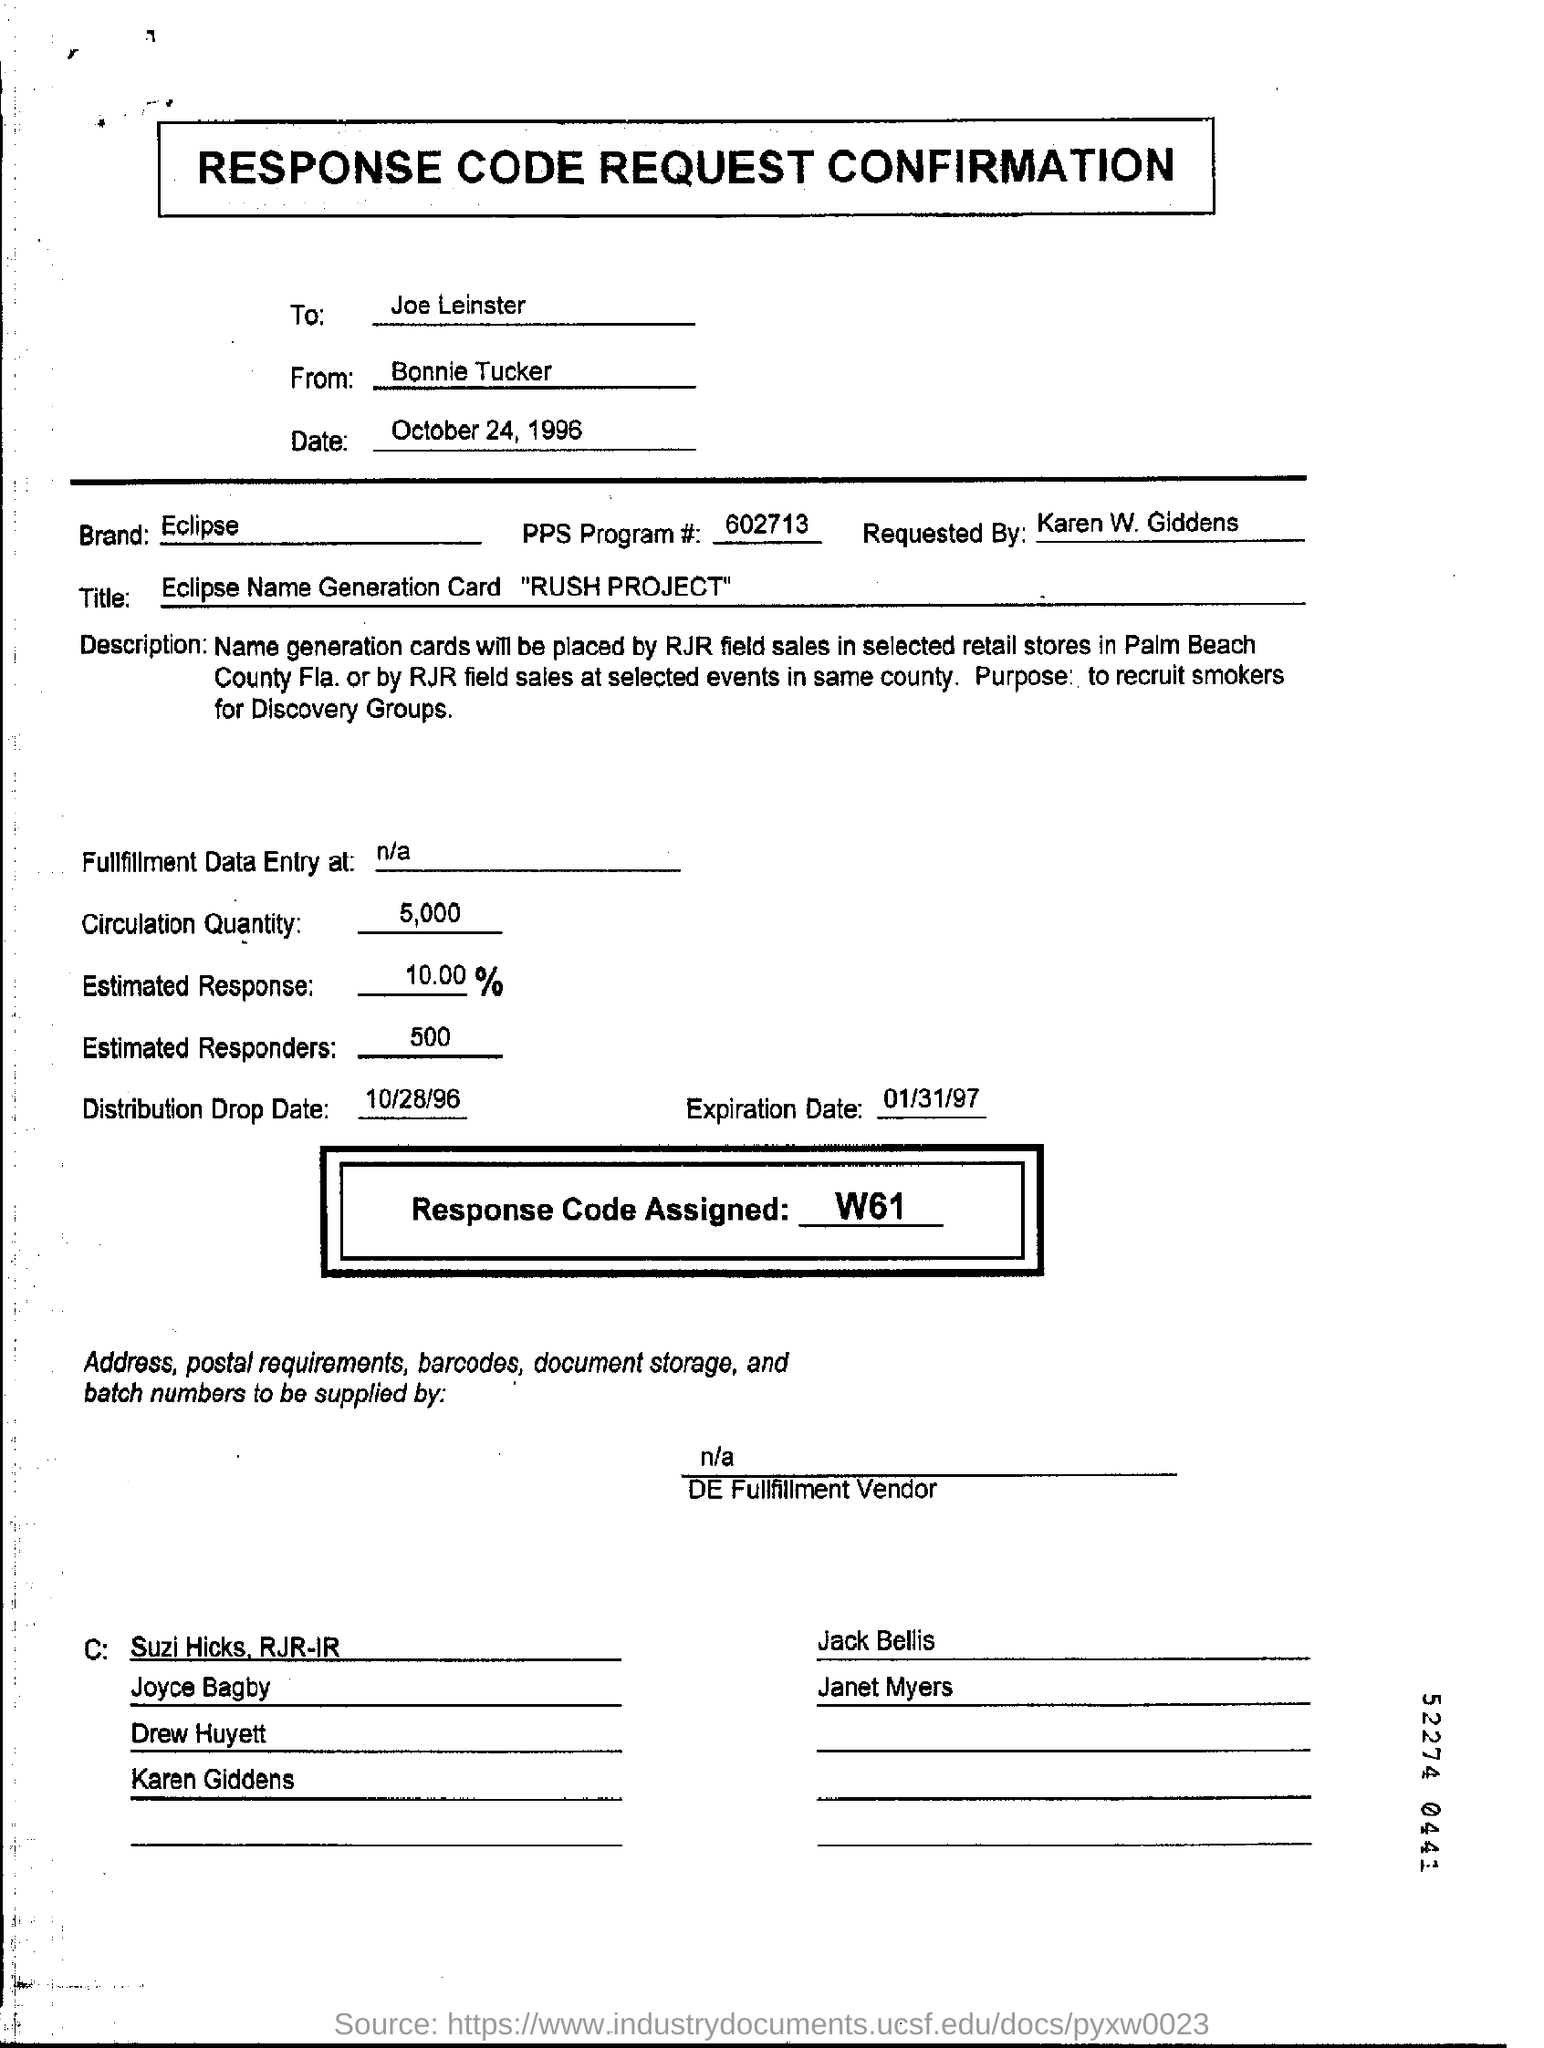To whom is this document addressed?
Make the answer very short. Joe Leinster. By whom is this document written?
Offer a very short reply. Bonnie Tucker. What is the date mentioned in the form?
Offer a very short reply. October 24, 1996. What is the response code assigned?
Offer a very short reply. W61. 